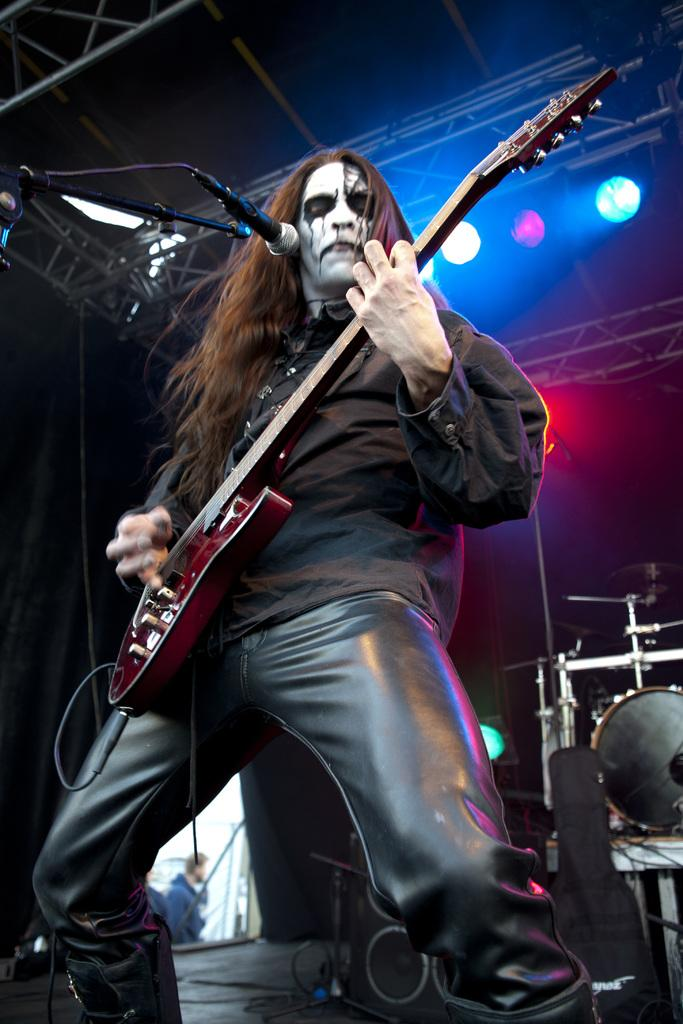What is the man in the image doing? The man is playing a guitar in the image. Where is the man positioned in relation to the microphone? The man is in front of a microphone. What can be seen in the background of the image? There are lights visible in the image. What type of vase is placed on the man's elbow in the image? There is no vase present on the man's elbow in the image; he is playing a guitar and standing in front of a microphone. 